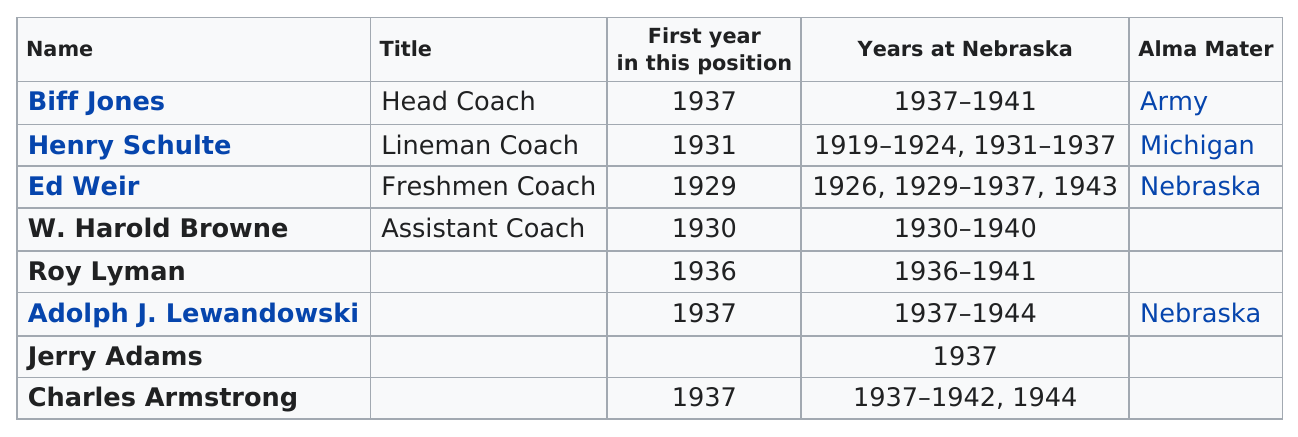Identify some key points in this picture. There were two coaches who started in the same year as Charles Armstrong: Biff Jones and Adolph J. Lewandowski. Henry Schulte held his coaching position for the most years among all coaches. The coaching staff of the 1937 Nebraska football team consisted of 8 people. It is reported that two coaches have Nebraska as their alma mater. Biff Jones coached for a total of four consecutive years. 